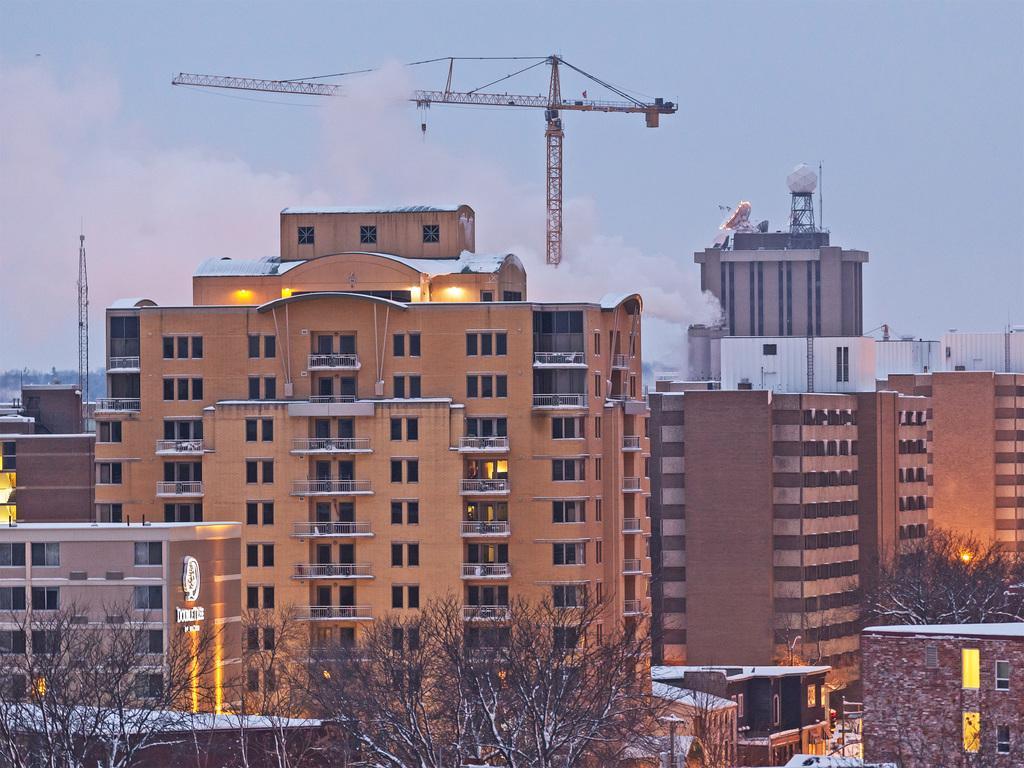In one or two sentences, can you explain what this image depicts? In this picture we can see many tall buildings, houses and trees in the front. In the background, we can see the sky is blue and there is a crane. 